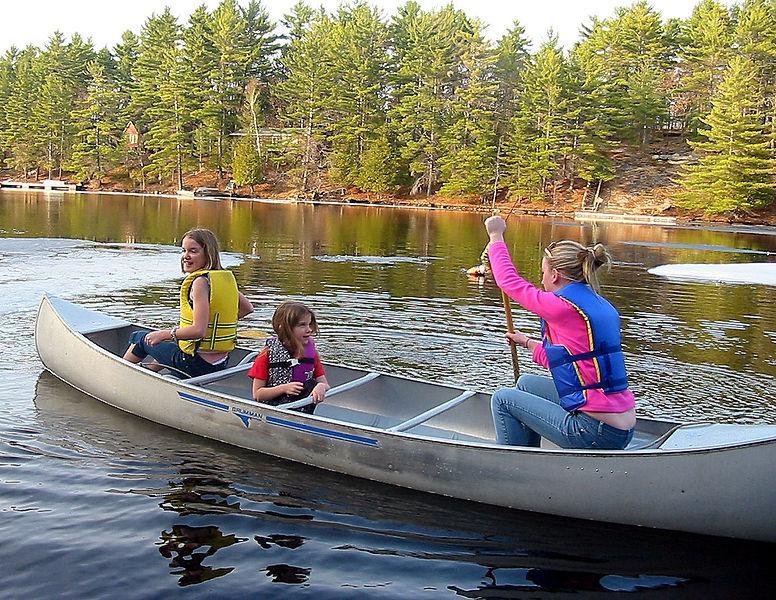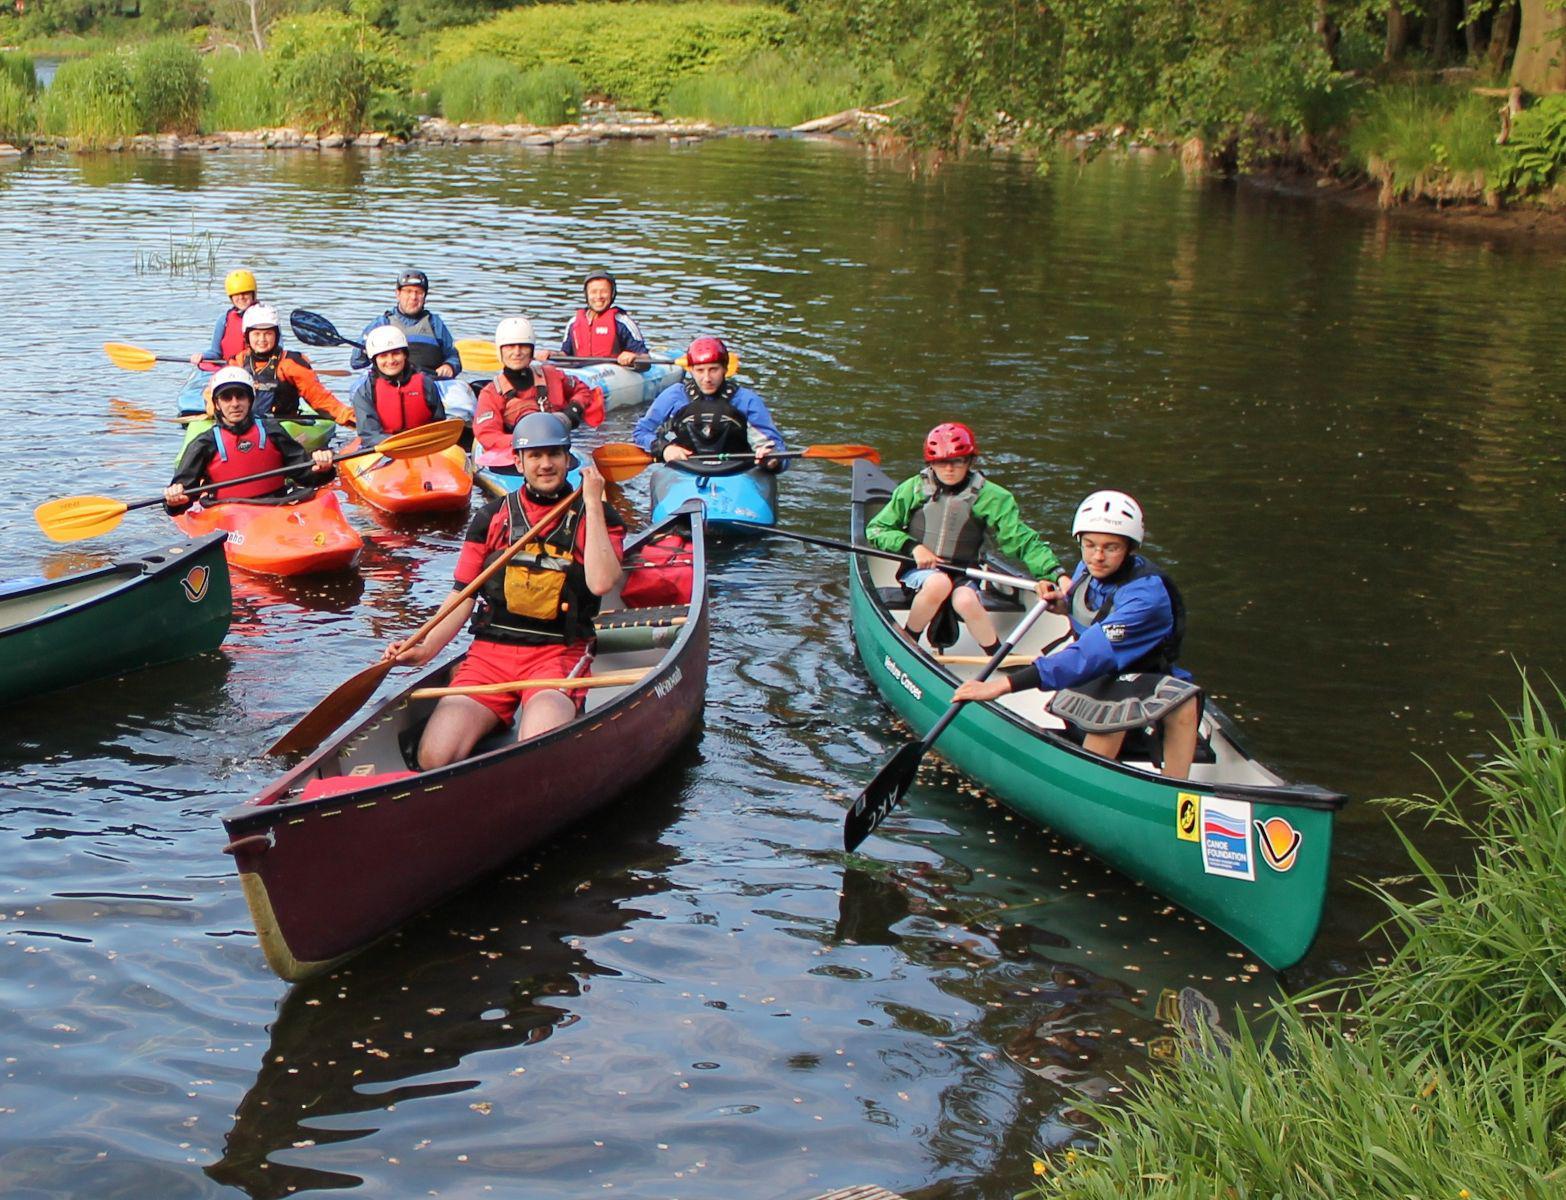The first image is the image on the left, the second image is the image on the right. Given the left and right images, does the statement "The left photo shows a single silver canoe with three passengers." hold true? Answer yes or no. Yes. The first image is the image on the left, the second image is the image on the right. Examine the images to the left and right. Is the description "One image shows exactly one silver canoe with 3 riders." accurate? Answer yes or no. Yes. 